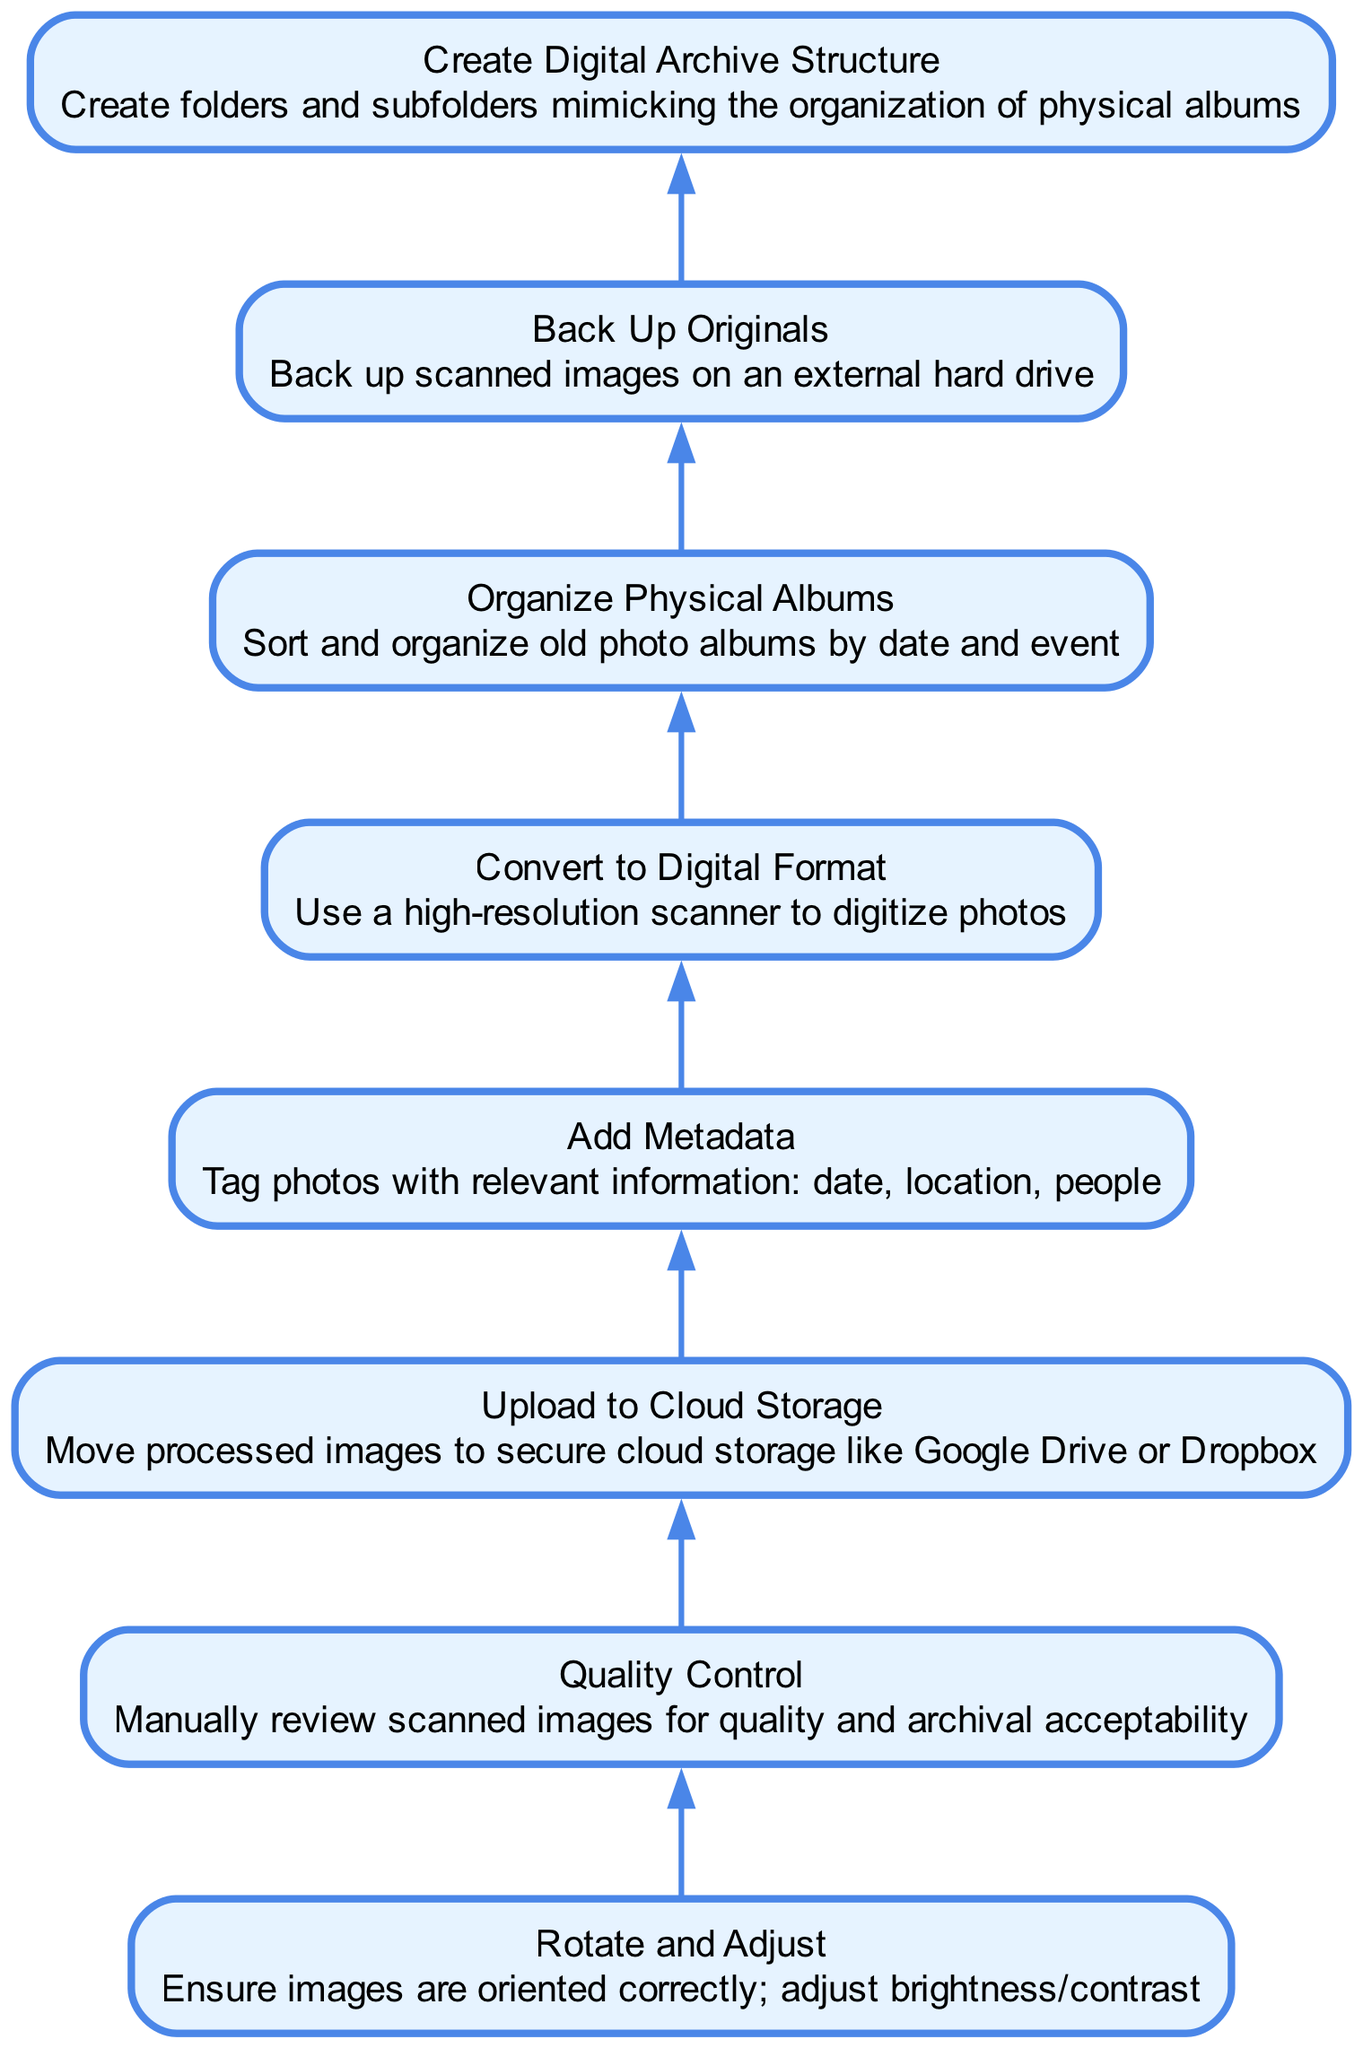what is the first step in the workflow? The first step in the workflow is represented at the bottom of the diagram. According to the flow from bottom to top, the node labeled "Organize Physical Albums" is the first action to be taken before any digitization can occur.
Answer: Organize Physical Albums how many nodes are in the diagram? To find the total number of nodes, we count each unique step in the workflow. There are a total of 8 distinct nodes listed in the diagram that represent various steps in the digitization and archiving process.
Answer: 8 what is the last step in the workflow? The last step can be determined by inspecting the topmost node in the diagram, which is "Upload to Cloud Storage". This indicates it is the final action taken in the workflow sequence following all previous steps.
Answer: Upload to Cloud Storage which step comes directly after "Convert to Digital Format"? The flowchart shows that "Add Metadata" directly follows "Convert to Digital Format". This indicates that once the photos are digitized, tagging them with relevant information is the next task in the sequence of actions.
Answer: Add Metadata what is the connection between "Back Up Originals" and "Quality Control"? The diagram creates a sequence where "Back Up Originals" is positioned after "Upload to Cloud Storage", while "Quality Control" occurs earlier in the process after "Rotate and Adjust". This indicates that "Quality Control" is an essential step that must be completed before backing up the originals, showcasing a flow from quality assessment to safeguarding digital copies.
Answer: Quality Control is before Back Up Originals 